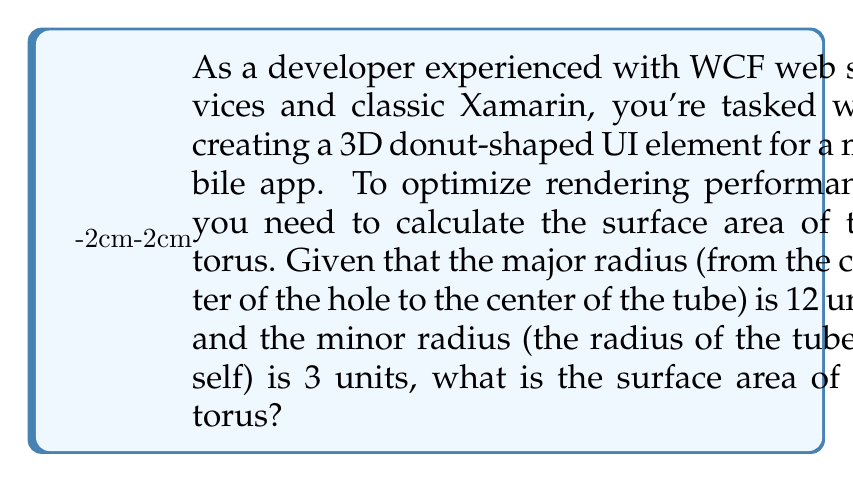Can you solve this math problem? To calculate the surface area of a torus, we use the formula:

$$A = 4\pi^2Rr$$

Where:
$A$ = surface area
$R$ = major radius (distance from the center of the hole to the center of the tube)
$r$ = minor radius (radius of the tube itself)

Let's break it down step-by-step:

1. Identify the given values:
   $R = 12$ units
   $r = 3$ units

2. Substitute these values into the formula:
   $$A = 4\pi^2 \cdot 12 \cdot 3$$

3. Simplify:
   $$A = 4\pi^2 \cdot 36$$
   $$A = 144\pi^2$$

4. Calculate the final value (rounded to two decimal places):
   $$A \approx 1,420.53\text{ square units}$$

[asy]
import geometry;

real R = 12;
real r = 3;
pair O = (0,0);

draw(circle(O, R), rgb(0,0,1));
draw(circle((R,0), r), rgb(1,0,0));
draw((R-r,0)--(R+r,0), dashed);
label("R", (R/2,0), S);
label("r", (R,r/2), E);

draw((-R-r,0)--(R+r,0), gray);
draw((0,-R-r)--(0,R+r), gray);
[/asy]

This diagram illustrates the torus with its major radius R and minor radius r.
Answer: The surface area of the torus is approximately 1,420.53 square units. 